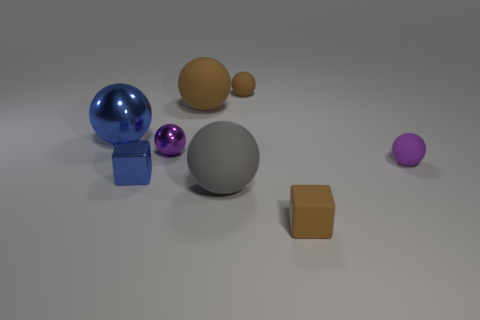The small rubber ball that is behind the big blue ball is what color?
Your answer should be compact. Brown. Is the number of blue things that are behind the large blue ball the same as the number of big gray rubber balls behind the tiny blue shiny object?
Ensure brevity in your answer.  Yes. What is the big sphere that is to the left of the tiny cube behind the tiny brown cube made of?
Your response must be concise. Metal. What number of things are tiny blue metal things or small brown things that are behind the blue block?
Make the answer very short. 2. What is the size of the purple sphere that is made of the same material as the gray ball?
Ensure brevity in your answer.  Small. Is the number of tiny metal blocks on the right side of the big gray matte object greater than the number of small rubber cubes?
Offer a very short reply. No. There is a rubber object that is in front of the blue block and left of the brown block; how big is it?
Offer a terse response. Large. There is a tiny brown object that is the same shape as the big blue metallic thing; what is it made of?
Keep it short and to the point. Rubber. There is a object left of the shiny block; is it the same size as the small blue block?
Provide a succinct answer. No. What color is the metallic object that is both behind the blue metal block and to the left of the tiny metal ball?
Provide a short and direct response. Blue. 